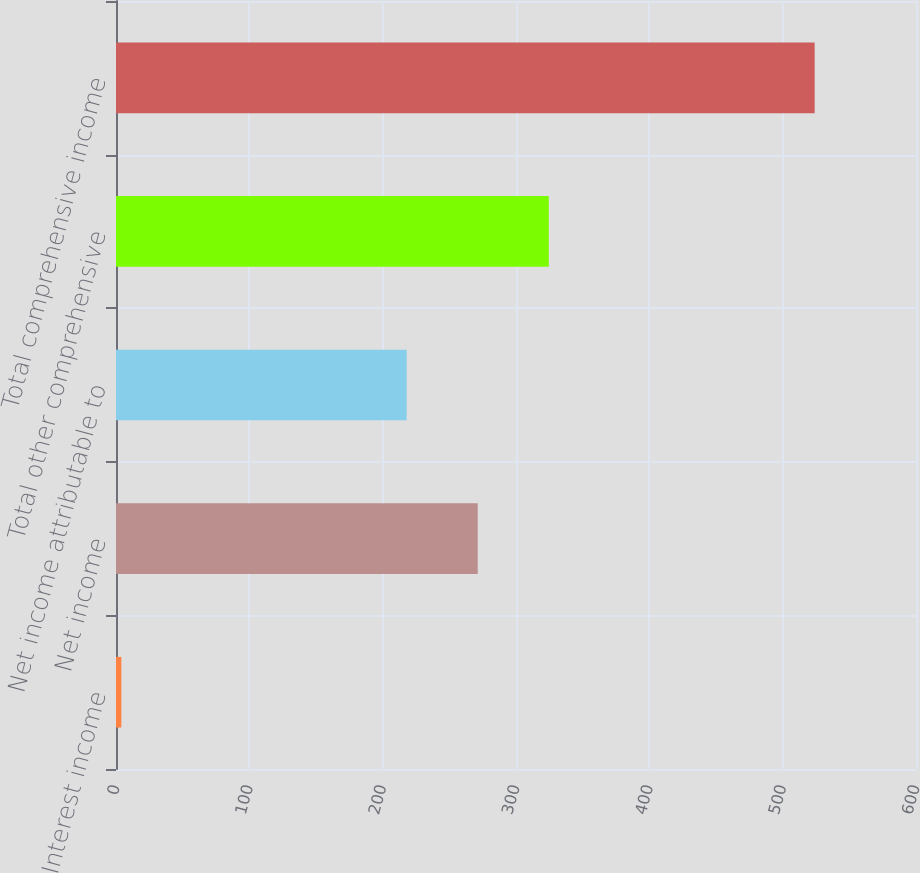<chart> <loc_0><loc_0><loc_500><loc_500><bar_chart><fcel>Interest income<fcel>Net income<fcel>Net income attributable to<fcel>Total other comprehensive<fcel>Total comprehensive income<nl><fcel>4<fcel>271.3<fcel>218<fcel>324.6<fcel>524<nl></chart> 